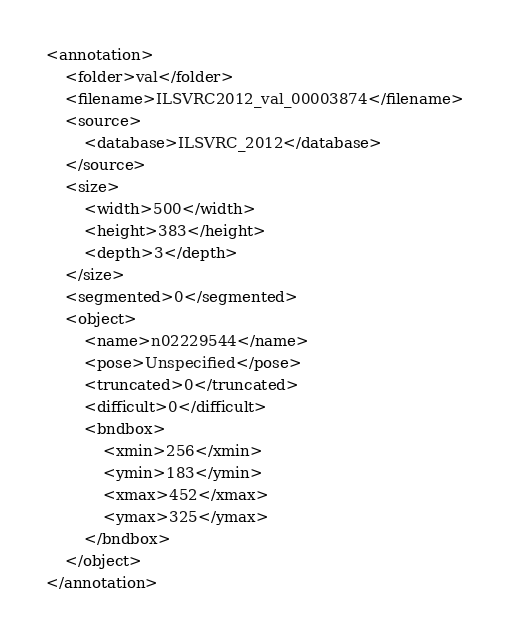<code> <loc_0><loc_0><loc_500><loc_500><_XML_><annotation>
	<folder>val</folder>
	<filename>ILSVRC2012_val_00003874</filename>
	<source>
		<database>ILSVRC_2012</database>
	</source>
	<size>
		<width>500</width>
		<height>383</height>
		<depth>3</depth>
	</size>
	<segmented>0</segmented>
	<object>
		<name>n02229544</name>
		<pose>Unspecified</pose>
		<truncated>0</truncated>
		<difficult>0</difficult>
		<bndbox>
			<xmin>256</xmin>
			<ymin>183</ymin>
			<xmax>452</xmax>
			<ymax>325</ymax>
		</bndbox>
	</object>
</annotation></code> 